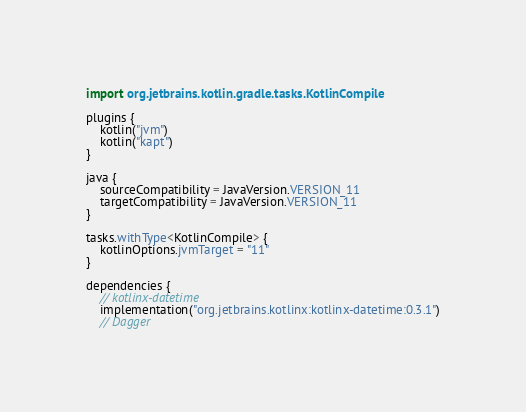<code> <loc_0><loc_0><loc_500><loc_500><_Kotlin_>import org.jetbrains.kotlin.gradle.tasks.KotlinCompile

plugins {
    kotlin("jvm")
    kotlin("kapt")
}

java {
    sourceCompatibility = JavaVersion.VERSION_11
    targetCompatibility = JavaVersion.VERSION_11
}

tasks.withType<KotlinCompile> {
    kotlinOptions.jvmTarget = "11"
}

dependencies {
    // kotlinx-datetime
    implementation("org.jetbrains.kotlinx:kotlinx-datetime:0.3.1")
    // Dagger</code> 